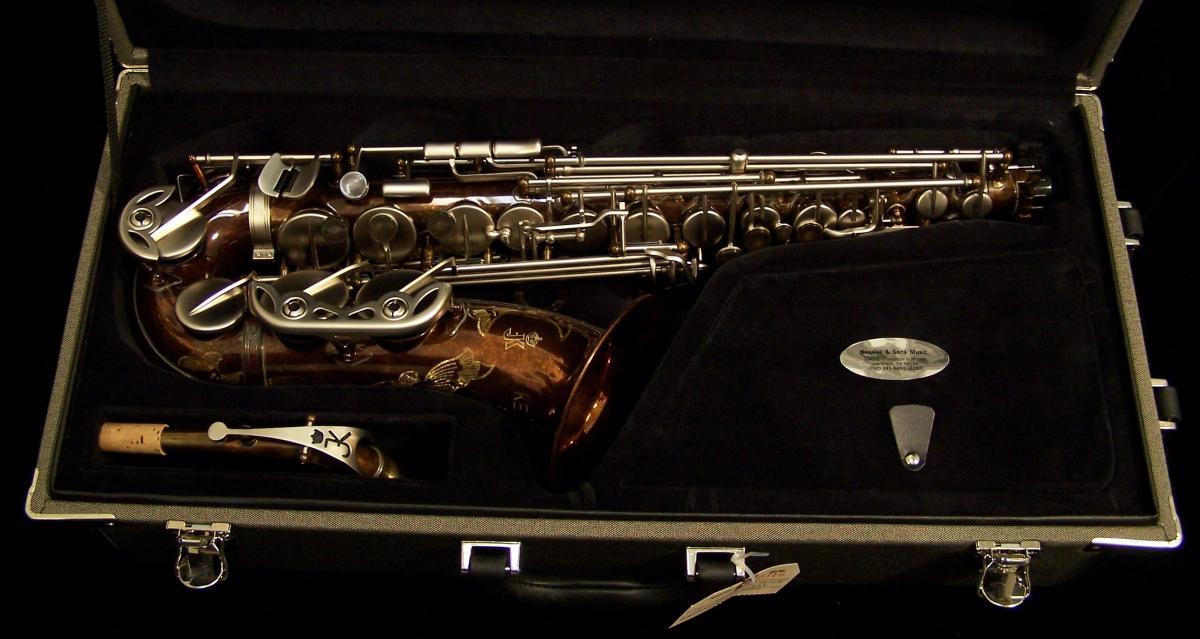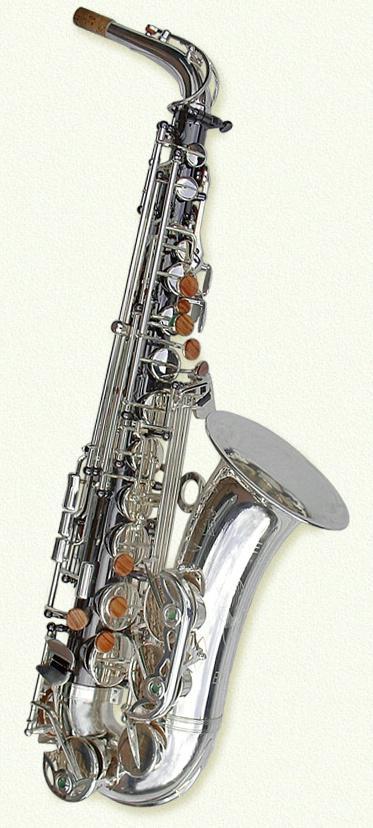The first image is the image on the left, the second image is the image on the right. For the images displayed, is the sentence "The saxophone on the right side is on a black background." factually correct? Answer yes or no. No. The first image is the image on the left, the second image is the image on the right. Evaluate the accuracy of this statement regarding the images: "there are two saxophones and one case in the pair of images.". Is it true? Answer yes or no. Yes. 